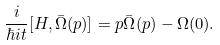Convert formula to latex. <formula><loc_0><loc_0><loc_500><loc_500>\frac { i } { \hbar { i } t } [ H , \bar { \Omega } ( p ) ] = p \bar { \Omega } ( p ) - \Omega ( 0 ) .</formula> 